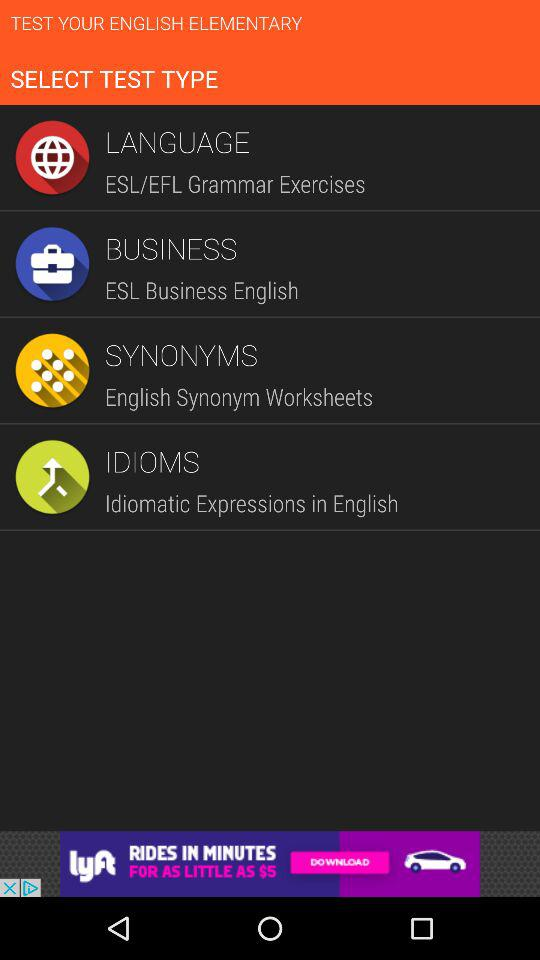How many test types are there?
Answer the question using a single word or phrase. 4 